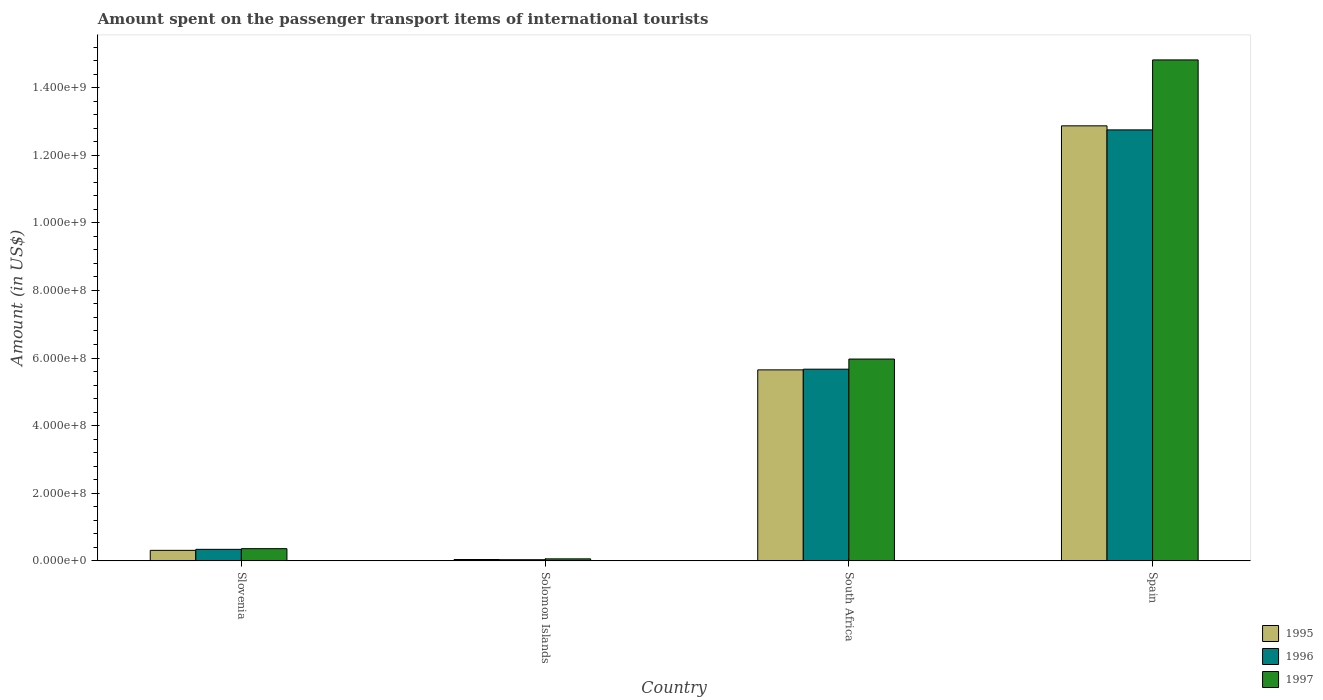How many groups of bars are there?
Make the answer very short. 4. Are the number of bars on each tick of the X-axis equal?
Keep it short and to the point. Yes. How many bars are there on the 3rd tick from the right?
Offer a terse response. 3. What is the label of the 3rd group of bars from the left?
Provide a short and direct response. South Africa. What is the amount spent on the passenger transport items of international tourists in 1997 in Spain?
Your response must be concise. 1.48e+09. Across all countries, what is the maximum amount spent on the passenger transport items of international tourists in 1997?
Provide a short and direct response. 1.48e+09. Across all countries, what is the minimum amount spent on the passenger transport items of international tourists in 1997?
Your answer should be compact. 5.80e+06. In which country was the amount spent on the passenger transport items of international tourists in 1996 maximum?
Keep it short and to the point. Spain. In which country was the amount spent on the passenger transport items of international tourists in 1996 minimum?
Your response must be concise. Solomon Islands. What is the total amount spent on the passenger transport items of international tourists in 1995 in the graph?
Give a very brief answer. 1.89e+09. What is the difference between the amount spent on the passenger transport items of international tourists in 1997 in Solomon Islands and that in Spain?
Offer a very short reply. -1.48e+09. What is the difference between the amount spent on the passenger transport items of international tourists in 1995 in Spain and the amount spent on the passenger transport items of international tourists in 1996 in Solomon Islands?
Offer a very short reply. 1.28e+09. What is the average amount spent on the passenger transport items of international tourists in 1997 per country?
Provide a short and direct response. 5.30e+08. What is the ratio of the amount spent on the passenger transport items of international tourists in 1996 in Slovenia to that in Spain?
Give a very brief answer. 0.03. What is the difference between the highest and the second highest amount spent on the passenger transport items of international tourists in 1995?
Ensure brevity in your answer.  7.22e+08. What is the difference between the highest and the lowest amount spent on the passenger transport items of international tourists in 1996?
Your response must be concise. 1.27e+09. In how many countries, is the amount spent on the passenger transport items of international tourists in 1996 greater than the average amount spent on the passenger transport items of international tourists in 1996 taken over all countries?
Your answer should be very brief. 2. What does the 2nd bar from the right in Solomon Islands represents?
Ensure brevity in your answer.  1996. Is it the case that in every country, the sum of the amount spent on the passenger transport items of international tourists in 1995 and amount spent on the passenger transport items of international tourists in 1997 is greater than the amount spent on the passenger transport items of international tourists in 1996?
Provide a succinct answer. Yes. How many bars are there?
Your answer should be compact. 12. Are the values on the major ticks of Y-axis written in scientific E-notation?
Provide a short and direct response. Yes. Does the graph contain grids?
Ensure brevity in your answer.  No. Where does the legend appear in the graph?
Ensure brevity in your answer.  Bottom right. How are the legend labels stacked?
Your response must be concise. Vertical. What is the title of the graph?
Offer a very short reply. Amount spent on the passenger transport items of international tourists. What is the label or title of the Y-axis?
Your answer should be compact. Amount (in US$). What is the Amount (in US$) of 1995 in Slovenia?
Make the answer very short. 3.10e+07. What is the Amount (in US$) of 1996 in Slovenia?
Provide a short and direct response. 3.40e+07. What is the Amount (in US$) in 1997 in Slovenia?
Offer a terse response. 3.60e+07. What is the Amount (in US$) of 1995 in Solomon Islands?
Provide a succinct answer. 3.90e+06. What is the Amount (in US$) of 1996 in Solomon Islands?
Your answer should be very brief. 3.30e+06. What is the Amount (in US$) in 1997 in Solomon Islands?
Make the answer very short. 5.80e+06. What is the Amount (in US$) of 1995 in South Africa?
Make the answer very short. 5.65e+08. What is the Amount (in US$) in 1996 in South Africa?
Give a very brief answer. 5.67e+08. What is the Amount (in US$) of 1997 in South Africa?
Give a very brief answer. 5.97e+08. What is the Amount (in US$) in 1995 in Spain?
Provide a short and direct response. 1.29e+09. What is the Amount (in US$) of 1996 in Spain?
Keep it short and to the point. 1.28e+09. What is the Amount (in US$) in 1997 in Spain?
Give a very brief answer. 1.48e+09. Across all countries, what is the maximum Amount (in US$) in 1995?
Ensure brevity in your answer.  1.29e+09. Across all countries, what is the maximum Amount (in US$) in 1996?
Your response must be concise. 1.28e+09. Across all countries, what is the maximum Amount (in US$) in 1997?
Make the answer very short. 1.48e+09. Across all countries, what is the minimum Amount (in US$) in 1995?
Your answer should be very brief. 3.90e+06. Across all countries, what is the minimum Amount (in US$) of 1996?
Make the answer very short. 3.30e+06. Across all countries, what is the minimum Amount (in US$) of 1997?
Your answer should be very brief. 5.80e+06. What is the total Amount (in US$) of 1995 in the graph?
Offer a very short reply. 1.89e+09. What is the total Amount (in US$) of 1996 in the graph?
Offer a very short reply. 1.88e+09. What is the total Amount (in US$) of 1997 in the graph?
Keep it short and to the point. 2.12e+09. What is the difference between the Amount (in US$) of 1995 in Slovenia and that in Solomon Islands?
Keep it short and to the point. 2.71e+07. What is the difference between the Amount (in US$) in 1996 in Slovenia and that in Solomon Islands?
Your answer should be very brief. 3.07e+07. What is the difference between the Amount (in US$) in 1997 in Slovenia and that in Solomon Islands?
Ensure brevity in your answer.  3.02e+07. What is the difference between the Amount (in US$) of 1995 in Slovenia and that in South Africa?
Make the answer very short. -5.34e+08. What is the difference between the Amount (in US$) of 1996 in Slovenia and that in South Africa?
Offer a very short reply. -5.33e+08. What is the difference between the Amount (in US$) of 1997 in Slovenia and that in South Africa?
Provide a succinct answer. -5.61e+08. What is the difference between the Amount (in US$) of 1995 in Slovenia and that in Spain?
Offer a terse response. -1.26e+09. What is the difference between the Amount (in US$) in 1996 in Slovenia and that in Spain?
Give a very brief answer. -1.24e+09. What is the difference between the Amount (in US$) of 1997 in Slovenia and that in Spain?
Your response must be concise. -1.45e+09. What is the difference between the Amount (in US$) in 1995 in Solomon Islands and that in South Africa?
Your response must be concise. -5.61e+08. What is the difference between the Amount (in US$) in 1996 in Solomon Islands and that in South Africa?
Make the answer very short. -5.64e+08. What is the difference between the Amount (in US$) in 1997 in Solomon Islands and that in South Africa?
Offer a very short reply. -5.91e+08. What is the difference between the Amount (in US$) in 1995 in Solomon Islands and that in Spain?
Offer a terse response. -1.28e+09. What is the difference between the Amount (in US$) of 1996 in Solomon Islands and that in Spain?
Your answer should be compact. -1.27e+09. What is the difference between the Amount (in US$) in 1997 in Solomon Islands and that in Spain?
Ensure brevity in your answer.  -1.48e+09. What is the difference between the Amount (in US$) of 1995 in South Africa and that in Spain?
Offer a terse response. -7.22e+08. What is the difference between the Amount (in US$) of 1996 in South Africa and that in Spain?
Your response must be concise. -7.08e+08. What is the difference between the Amount (in US$) of 1997 in South Africa and that in Spain?
Provide a succinct answer. -8.85e+08. What is the difference between the Amount (in US$) in 1995 in Slovenia and the Amount (in US$) in 1996 in Solomon Islands?
Provide a short and direct response. 2.77e+07. What is the difference between the Amount (in US$) in 1995 in Slovenia and the Amount (in US$) in 1997 in Solomon Islands?
Make the answer very short. 2.52e+07. What is the difference between the Amount (in US$) in 1996 in Slovenia and the Amount (in US$) in 1997 in Solomon Islands?
Keep it short and to the point. 2.82e+07. What is the difference between the Amount (in US$) in 1995 in Slovenia and the Amount (in US$) in 1996 in South Africa?
Provide a succinct answer. -5.36e+08. What is the difference between the Amount (in US$) in 1995 in Slovenia and the Amount (in US$) in 1997 in South Africa?
Offer a terse response. -5.66e+08. What is the difference between the Amount (in US$) of 1996 in Slovenia and the Amount (in US$) of 1997 in South Africa?
Give a very brief answer. -5.63e+08. What is the difference between the Amount (in US$) of 1995 in Slovenia and the Amount (in US$) of 1996 in Spain?
Give a very brief answer. -1.24e+09. What is the difference between the Amount (in US$) of 1995 in Slovenia and the Amount (in US$) of 1997 in Spain?
Keep it short and to the point. -1.45e+09. What is the difference between the Amount (in US$) of 1996 in Slovenia and the Amount (in US$) of 1997 in Spain?
Keep it short and to the point. -1.45e+09. What is the difference between the Amount (in US$) of 1995 in Solomon Islands and the Amount (in US$) of 1996 in South Africa?
Offer a very short reply. -5.63e+08. What is the difference between the Amount (in US$) of 1995 in Solomon Islands and the Amount (in US$) of 1997 in South Africa?
Give a very brief answer. -5.93e+08. What is the difference between the Amount (in US$) of 1996 in Solomon Islands and the Amount (in US$) of 1997 in South Africa?
Offer a very short reply. -5.94e+08. What is the difference between the Amount (in US$) in 1995 in Solomon Islands and the Amount (in US$) in 1996 in Spain?
Your answer should be compact. -1.27e+09. What is the difference between the Amount (in US$) in 1995 in Solomon Islands and the Amount (in US$) in 1997 in Spain?
Make the answer very short. -1.48e+09. What is the difference between the Amount (in US$) of 1996 in Solomon Islands and the Amount (in US$) of 1997 in Spain?
Your response must be concise. -1.48e+09. What is the difference between the Amount (in US$) in 1995 in South Africa and the Amount (in US$) in 1996 in Spain?
Ensure brevity in your answer.  -7.10e+08. What is the difference between the Amount (in US$) of 1995 in South Africa and the Amount (in US$) of 1997 in Spain?
Give a very brief answer. -9.17e+08. What is the difference between the Amount (in US$) of 1996 in South Africa and the Amount (in US$) of 1997 in Spain?
Offer a terse response. -9.15e+08. What is the average Amount (in US$) in 1995 per country?
Provide a succinct answer. 4.72e+08. What is the average Amount (in US$) of 1996 per country?
Provide a succinct answer. 4.70e+08. What is the average Amount (in US$) in 1997 per country?
Make the answer very short. 5.30e+08. What is the difference between the Amount (in US$) of 1995 and Amount (in US$) of 1996 in Slovenia?
Give a very brief answer. -3.00e+06. What is the difference between the Amount (in US$) of 1995 and Amount (in US$) of 1997 in Slovenia?
Provide a short and direct response. -5.00e+06. What is the difference between the Amount (in US$) of 1996 and Amount (in US$) of 1997 in Slovenia?
Your answer should be compact. -2.00e+06. What is the difference between the Amount (in US$) in 1995 and Amount (in US$) in 1996 in Solomon Islands?
Your answer should be compact. 6.00e+05. What is the difference between the Amount (in US$) in 1995 and Amount (in US$) in 1997 in Solomon Islands?
Give a very brief answer. -1.90e+06. What is the difference between the Amount (in US$) in 1996 and Amount (in US$) in 1997 in Solomon Islands?
Keep it short and to the point. -2.50e+06. What is the difference between the Amount (in US$) in 1995 and Amount (in US$) in 1997 in South Africa?
Provide a succinct answer. -3.20e+07. What is the difference between the Amount (in US$) in 1996 and Amount (in US$) in 1997 in South Africa?
Provide a short and direct response. -3.00e+07. What is the difference between the Amount (in US$) in 1995 and Amount (in US$) in 1997 in Spain?
Give a very brief answer. -1.95e+08. What is the difference between the Amount (in US$) in 1996 and Amount (in US$) in 1997 in Spain?
Offer a very short reply. -2.07e+08. What is the ratio of the Amount (in US$) in 1995 in Slovenia to that in Solomon Islands?
Ensure brevity in your answer.  7.95. What is the ratio of the Amount (in US$) of 1996 in Slovenia to that in Solomon Islands?
Offer a very short reply. 10.3. What is the ratio of the Amount (in US$) in 1997 in Slovenia to that in Solomon Islands?
Provide a succinct answer. 6.21. What is the ratio of the Amount (in US$) of 1995 in Slovenia to that in South Africa?
Offer a terse response. 0.05. What is the ratio of the Amount (in US$) in 1997 in Slovenia to that in South Africa?
Provide a succinct answer. 0.06. What is the ratio of the Amount (in US$) in 1995 in Slovenia to that in Spain?
Make the answer very short. 0.02. What is the ratio of the Amount (in US$) of 1996 in Slovenia to that in Spain?
Offer a very short reply. 0.03. What is the ratio of the Amount (in US$) in 1997 in Slovenia to that in Spain?
Offer a terse response. 0.02. What is the ratio of the Amount (in US$) of 1995 in Solomon Islands to that in South Africa?
Your response must be concise. 0.01. What is the ratio of the Amount (in US$) of 1996 in Solomon Islands to that in South Africa?
Your response must be concise. 0.01. What is the ratio of the Amount (in US$) of 1997 in Solomon Islands to that in South Africa?
Ensure brevity in your answer.  0.01. What is the ratio of the Amount (in US$) in 1995 in Solomon Islands to that in Spain?
Provide a succinct answer. 0. What is the ratio of the Amount (in US$) of 1996 in Solomon Islands to that in Spain?
Your answer should be compact. 0. What is the ratio of the Amount (in US$) of 1997 in Solomon Islands to that in Spain?
Make the answer very short. 0. What is the ratio of the Amount (in US$) of 1995 in South Africa to that in Spain?
Make the answer very short. 0.44. What is the ratio of the Amount (in US$) in 1996 in South Africa to that in Spain?
Provide a succinct answer. 0.44. What is the ratio of the Amount (in US$) of 1997 in South Africa to that in Spain?
Give a very brief answer. 0.4. What is the difference between the highest and the second highest Amount (in US$) of 1995?
Your response must be concise. 7.22e+08. What is the difference between the highest and the second highest Amount (in US$) in 1996?
Ensure brevity in your answer.  7.08e+08. What is the difference between the highest and the second highest Amount (in US$) of 1997?
Your answer should be very brief. 8.85e+08. What is the difference between the highest and the lowest Amount (in US$) of 1995?
Offer a very short reply. 1.28e+09. What is the difference between the highest and the lowest Amount (in US$) in 1996?
Offer a terse response. 1.27e+09. What is the difference between the highest and the lowest Amount (in US$) of 1997?
Your answer should be very brief. 1.48e+09. 